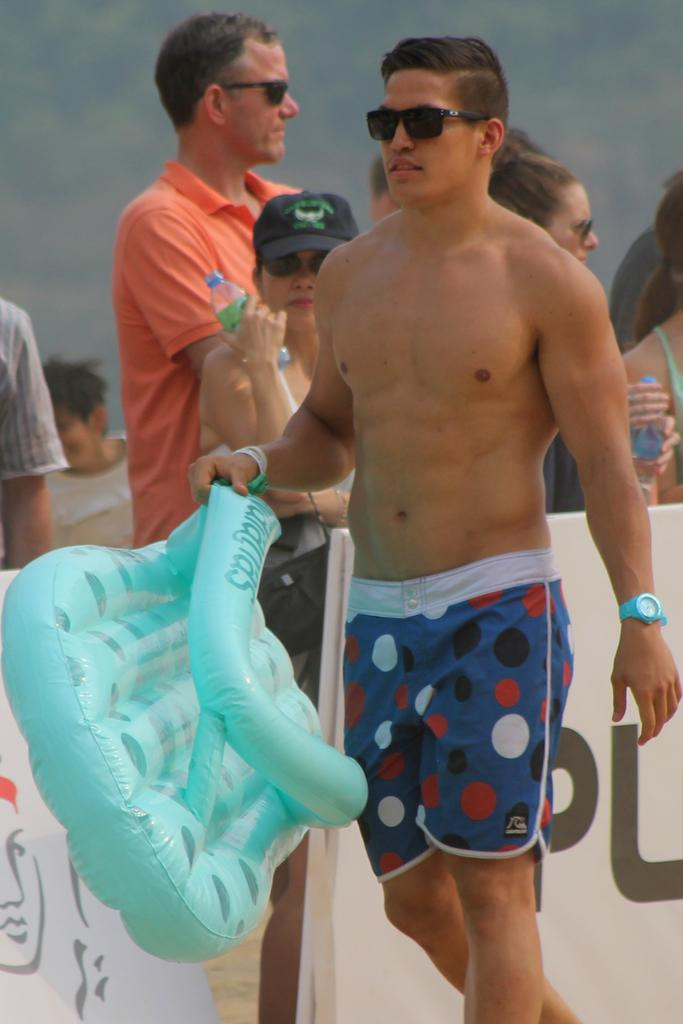What is the person in the image holding? The person in the image is holding a tube. Can you describe the scene in the background of the image? There are other people visible in the background of the image. What type of crook can be seen in the image? There is no crook present in the image. What observation can be made about the person holding the tube in the image? The provided facts do not give any information about the person's actions or expressions, so it is not possible to make an observation about them. 